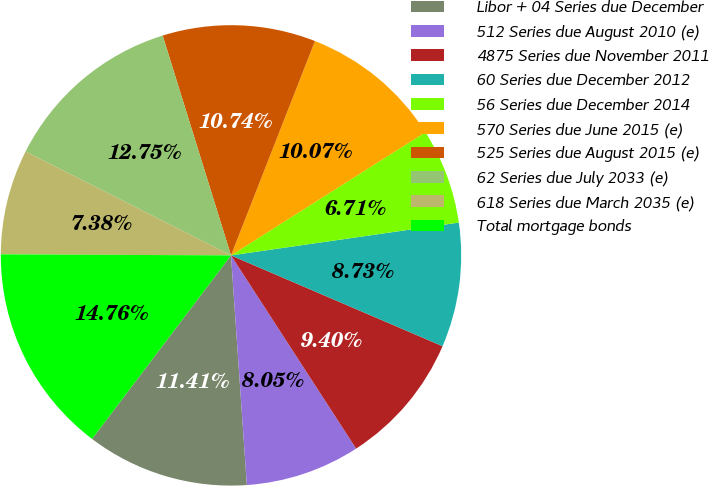Convert chart to OTSL. <chart><loc_0><loc_0><loc_500><loc_500><pie_chart><fcel>Libor + 04 Series due December<fcel>512 Series due August 2010 (e)<fcel>4875 Series due November 2011<fcel>60 Series due December 2012<fcel>56 Series due December 2014<fcel>570 Series due June 2015 (e)<fcel>525 Series due August 2015 (e)<fcel>62 Series due July 2033 (e)<fcel>618 Series due March 2035 (e)<fcel>Total mortgage bonds<nl><fcel>11.41%<fcel>8.05%<fcel>9.4%<fcel>8.73%<fcel>6.71%<fcel>10.07%<fcel>10.74%<fcel>12.75%<fcel>7.38%<fcel>14.76%<nl></chart> 